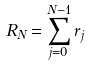<formula> <loc_0><loc_0><loc_500><loc_500>R _ { N } = \sum ^ { N - 1 } _ { j = 0 } r _ { j }</formula> 